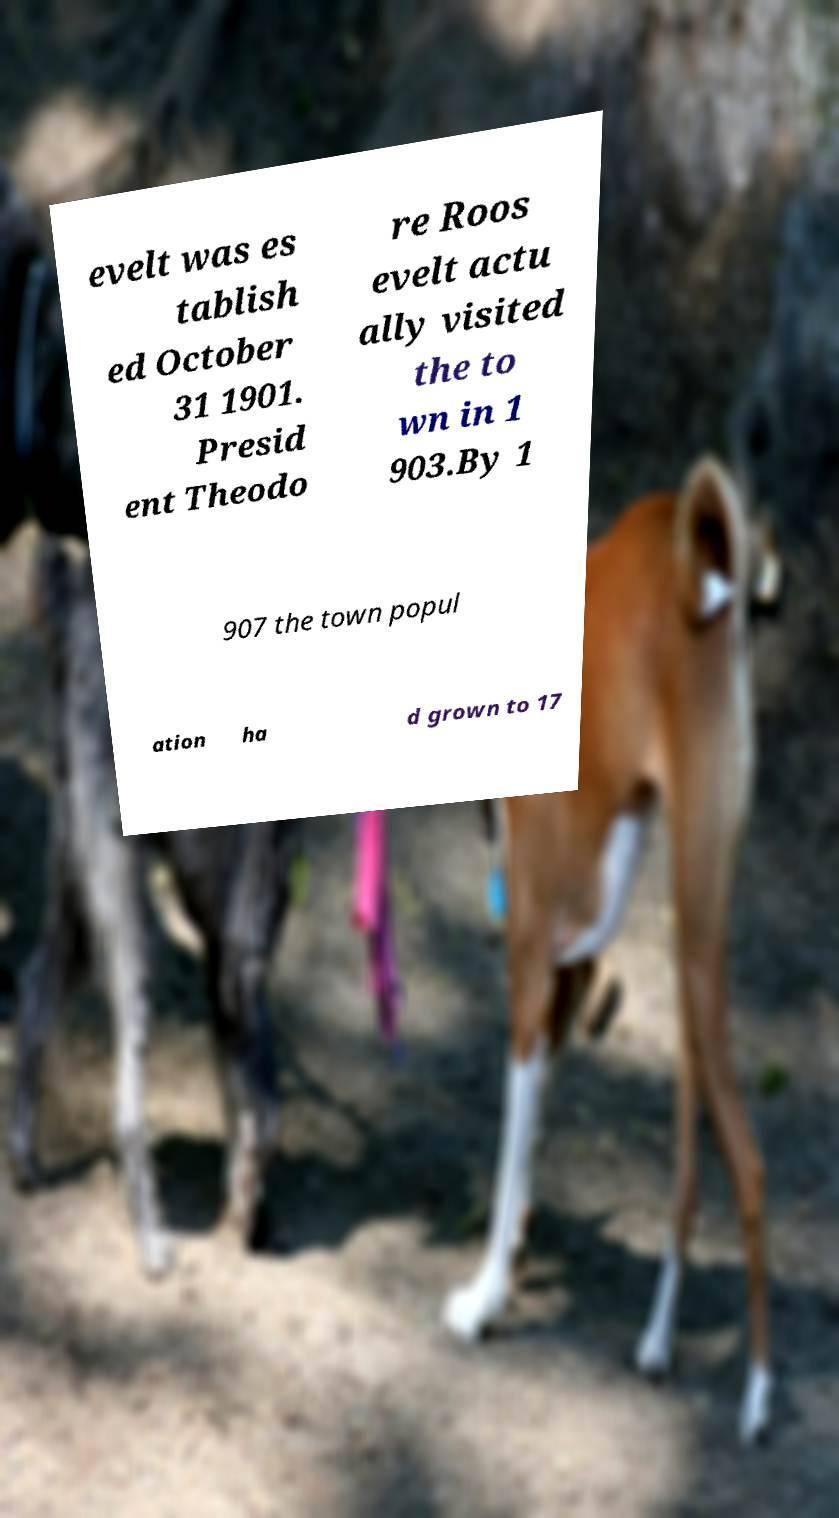For documentation purposes, I need the text within this image transcribed. Could you provide that? evelt was es tablish ed October 31 1901. Presid ent Theodo re Roos evelt actu ally visited the to wn in 1 903.By 1 907 the town popul ation ha d grown to 17 